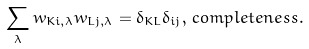<formula> <loc_0><loc_0><loc_500><loc_500>\sum _ { \lambda } w _ { K i , \lambda } w _ { L j , \lambda } = \delta _ { K L } \delta _ { i j } , \, c o m p l e t e n e s s .</formula> 